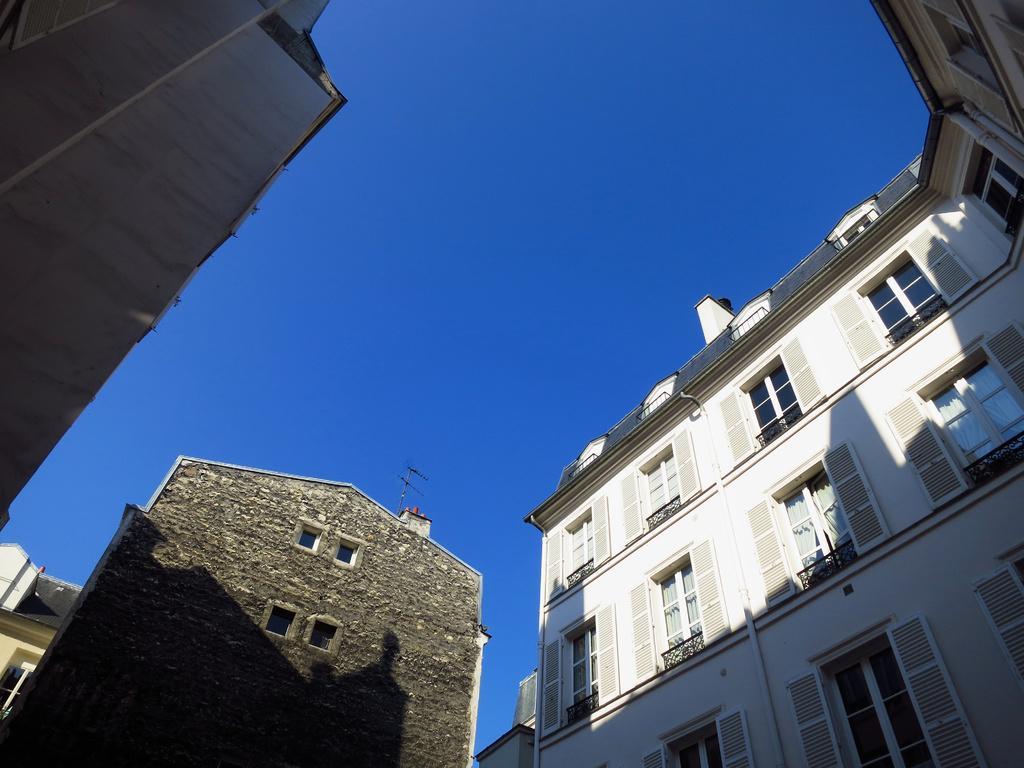Describe this image in one or two sentences. In the image there are few buildings, they are of different shape and color and the image is captured from the ground. 